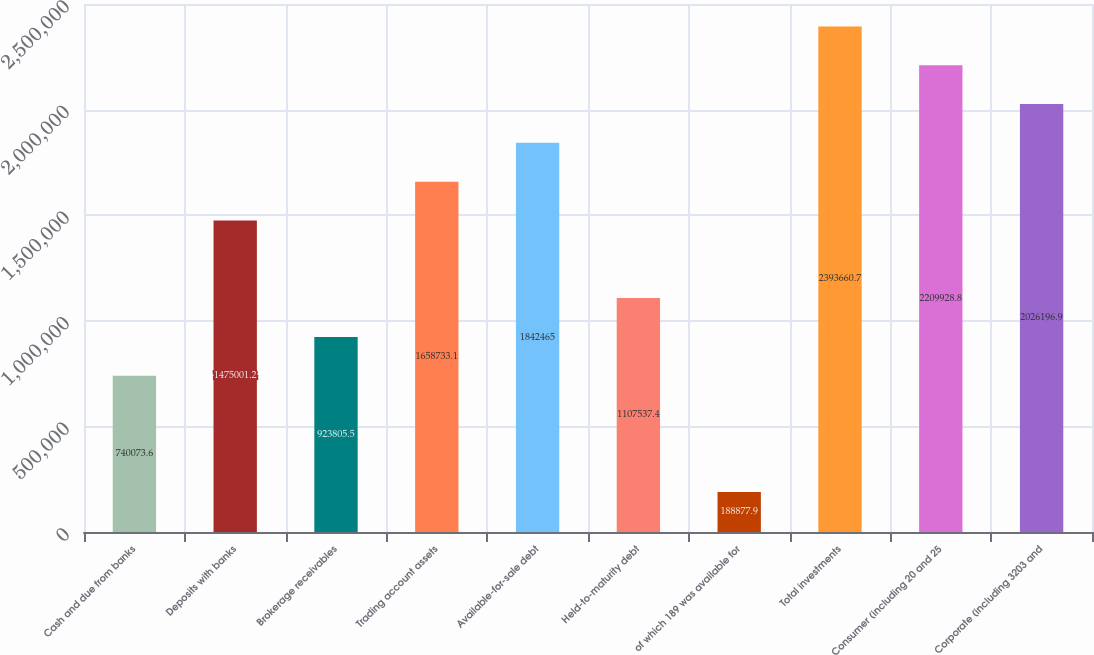Convert chart to OTSL. <chart><loc_0><loc_0><loc_500><loc_500><bar_chart><fcel>Cash and due from banks<fcel>Deposits with banks<fcel>Brokerage receivables<fcel>Trading account assets<fcel>Available-for-sale debt<fcel>Held-to-maturity debt<fcel>of which 189 was available for<fcel>Total investments<fcel>Consumer (including 20 and 25<fcel>Corporate (including 3203 and<nl><fcel>740074<fcel>1.475e+06<fcel>923806<fcel>1.65873e+06<fcel>1.84246e+06<fcel>1.10754e+06<fcel>188878<fcel>2.39366e+06<fcel>2.20993e+06<fcel>2.0262e+06<nl></chart> 